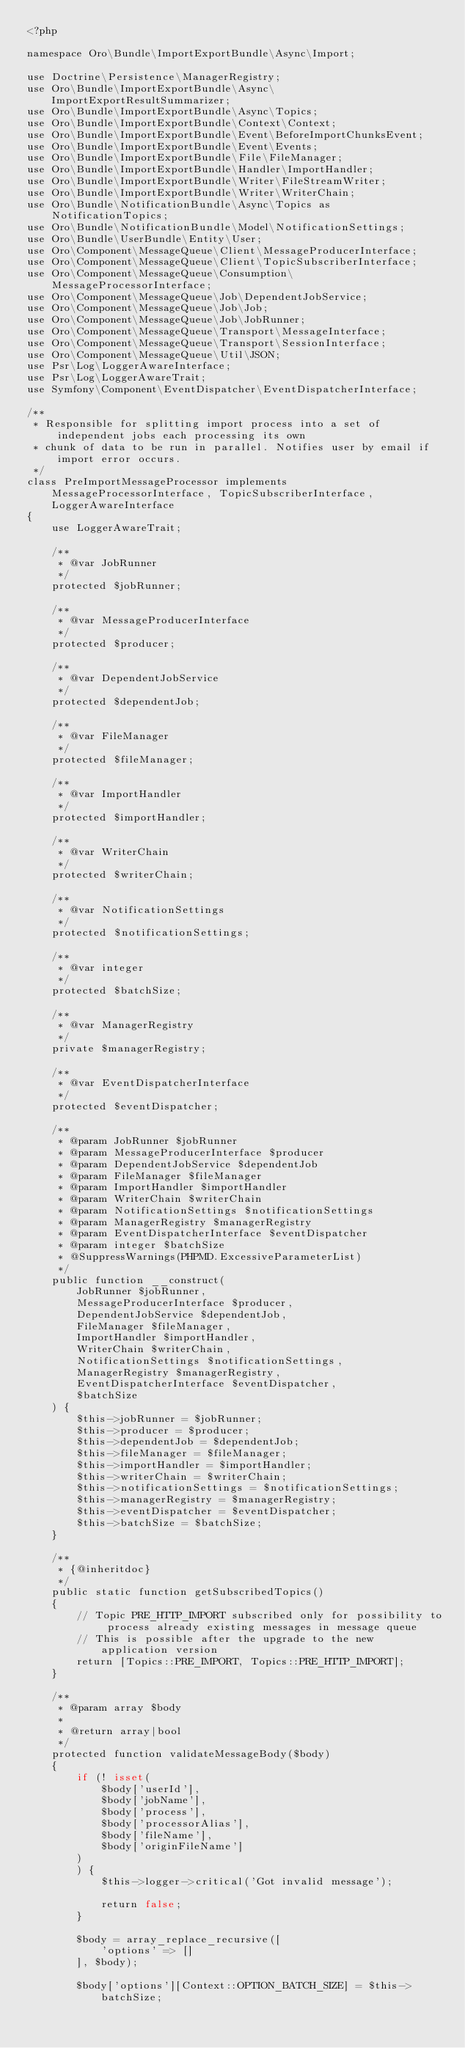Convert code to text. <code><loc_0><loc_0><loc_500><loc_500><_PHP_><?php

namespace Oro\Bundle\ImportExportBundle\Async\Import;

use Doctrine\Persistence\ManagerRegistry;
use Oro\Bundle\ImportExportBundle\Async\ImportExportResultSummarizer;
use Oro\Bundle\ImportExportBundle\Async\Topics;
use Oro\Bundle\ImportExportBundle\Context\Context;
use Oro\Bundle\ImportExportBundle\Event\BeforeImportChunksEvent;
use Oro\Bundle\ImportExportBundle\Event\Events;
use Oro\Bundle\ImportExportBundle\File\FileManager;
use Oro\Bundle\ImportExportBundle\Handler\ImportHandler;
use Oro\Bundle\ImportExportBundle\Writer\FileStreamWriter;
use Oro\Bundle\ImportExportBundle\Writer\WriterChain;
use Oro\Bundle\NotificationBundle\Async\Topics as NotificationTopics;
use Oro\Bundle\NotificationBundle\Model\NotificationSettings;
use Oro\Bundle\UserBundle\Entity\User;
use Oro\Component\MessageQueue\Client\MessageProducerInterface;
use Oro\Component\MessageQueue\Client\TopicSubscriberInterface;
use Oro\Component\MessageQueue\Consumption\MessageProcessorInterface;
use Oro\Component\MessageQueue\Job\DependentJobService;
use Oro\Component\MessageQueue\Job\Job;
use Oro\Component\MessageQueue\Job\JobRunner;
use Oro\Component\MessageQueue\Transport\MessageInterface;
use Oro\Component\MessageQueue\Transport\SessionInterface;
use Oro\Component\MessageQueue\Util\JSON;
use Psr\Log\LoggerAwareInterface;
use Psr\Log\LoggerAwareTrait;
use Symfony\Component\EventDispatcher\EventDispatcherInterface;

/**
 * Responsible for splitting import process into a set of independent jobs each processing its own
 * chunk of data to be run in parallel. Notifies user by email if import error occurs.
 */
class PreImportMessageProcessor implements MessageProcessorInterface, TopicSubscriberInterface, LoggerAwareInterface
{
    use LoggerAwareTrait;

    /**
     * @var JobRunner
     */
    protected $jobRunner;

    /**
     * @var MessageProducerInterface
     */
    protected $producer;

    /**
     * @var DependentJobService
     */
    protected $dependentJob;

    /**
     * @var FileManager
     */
    protected $fileManager;

    /**
     * @var ImportHandler
     */
    protected $importHandler;

    /**
     * @var WriterChain
     */
    protected $writerChain;

    /**
     * @var NotificationSettings
     */
    protected $notificationSettings;

    /**
     * @var integer
     */
    protected $batchSize;

    /**
     * @var ManagerRegistry
     */
    private $managerRegistry;

    /**
     * @var EventDispatcherInterface
     */
    protected $eventDispatcher;

    /**
     * @param JobRunner $jobRunner
     * @param MessageProducerInterface $producer
     * @param DependentJobService $dependentJob
     * @param FileManager $fileManager
     * @param ImportHandler $importHandler
     * @param WriterChain $writerChain
     * @param NotificationSettings $notificationSettings
     * @param ManagerRegistry $managerRegistry
     * @param EventDispatcherInterface $eventDispatcher
     * @param integer $batchSize
     * @SuppressWarnings(PHPMD.ExcessiveParameterList)
     */
    public function __construct(
        JobRunner $jobRunner,
        MessageProducerInterface $producer,
        DependentJobService $dependentJob,
        FileManager $fileManager,
        ImportHandler $importHandler,
        WriterChain $writerChain,
        NotificationSettings $notificationSettings,
        ManagerRegistry $managerRegistry,
        EventDispatcherInterface $eventDispatcher,
        $batchSize
    ) {
        $this->jobRunner = $jobRunner;
        $this->producer = $producer;
        $this->dependentJob = $dependentJob;
        $this->fileManager = $fileManager;
        $this->importHandler = $importHandler;
        $this->writerChain = $writerChain;
        $this->notificationSettings = $notificationSettings;
        $this->managerRegistry = $managerRegistry;
        $this->eventDispatcher = $eventDispatcher;
        $this->batchSize = $batchSize;
    }

    /**
     * {@inheritdoc}
     */
    public static function getSubscribedTopics()
    {
        // Topic PRE_HTTP_IMPORT subscribed only for possibility to process already existing messages in message queue
        // This is possible after the upgrade to the new application version
        return [Topics::PRE_IMPORT, Topics::PRE_HTTP_IMPORT];
    }

    /**
     * @param array $body
     *
     * @return array|bool
     */
    protected function validateMessageBody($body)
    {
        if (! isset(
            $body['userId'],
            $body['jobName'],
            $body['process'],
            $body['processorAlias'],
            $body['fileName'],
            $body['originFileName']
        )
        ) {
            $this->logger->critical('Got invalid message');

            return false;
        }

        $body = array_replace_recursive([
            'options' => []
        ], $body);

        $body['options'][Context::OPTION_BATCH_SIZE] = $this->batchSize;
</code> 